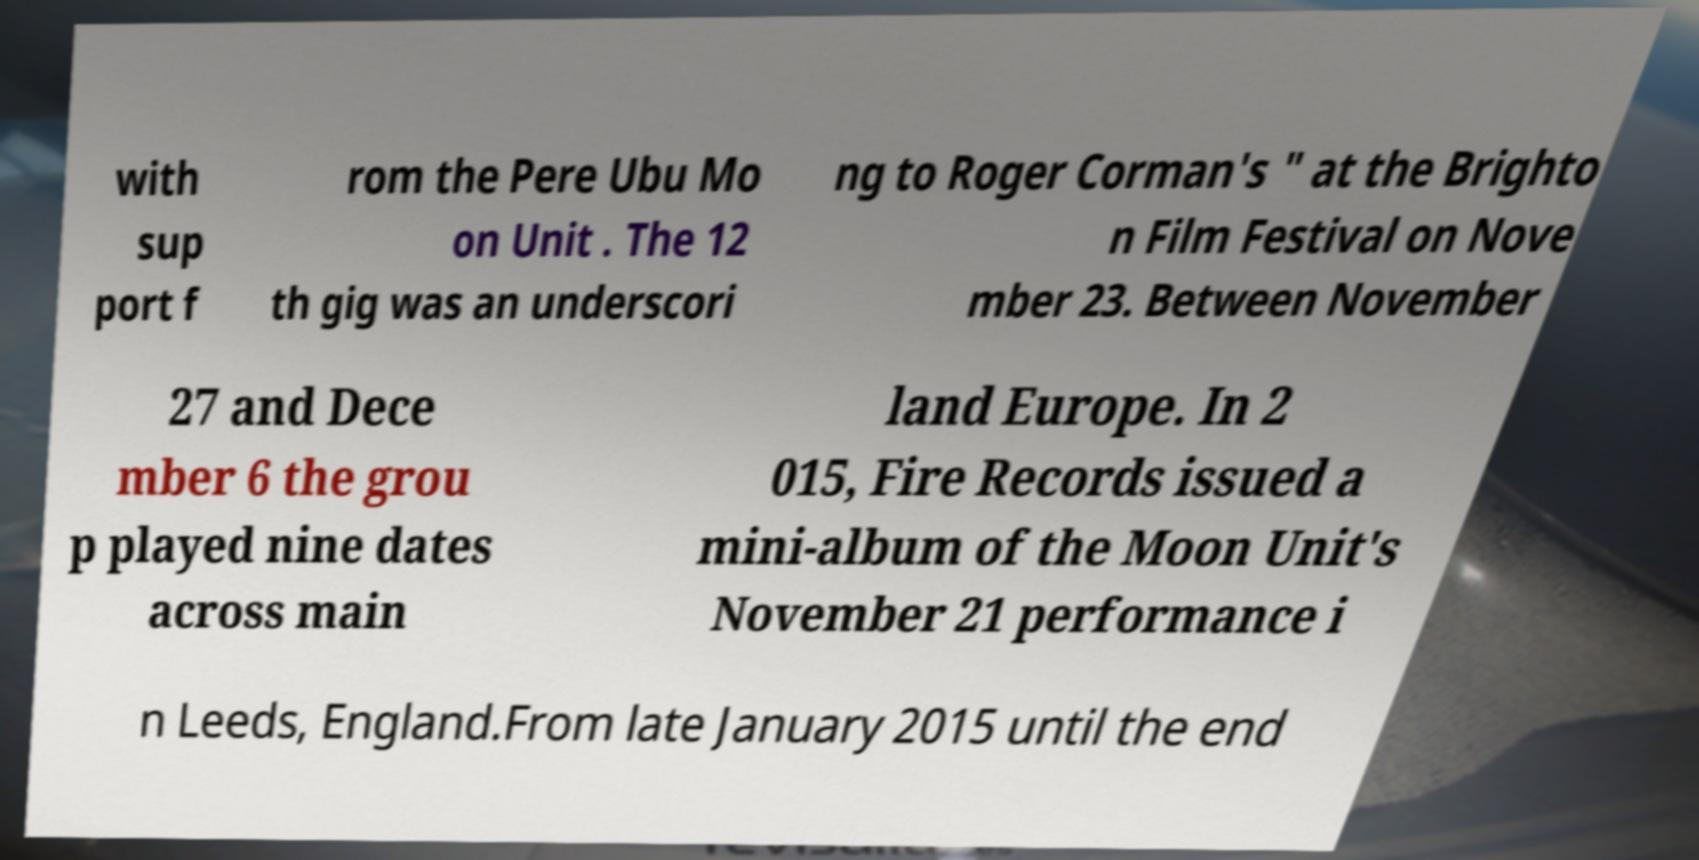Please identify and transcribe the text found in this image. with sup port f rom the Pere Ubu Mo on Unit . The 12 th gig was an underscori ng to Roger Corman's " at the Brighto n Film Festival on Nove mber 23. Between November 27 and Dece mber 6 the grou p played nine dates across main land Europe. In 2 015, Fire Records issued a mini-album of the Moon Unit's November 21 performance i n Leeds, England.From late January 2015 until the end 